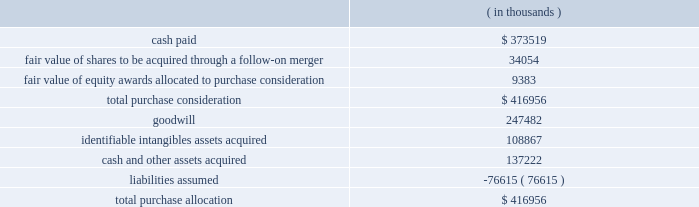Synopsys , inc .
Notes to consolidated financial statements 2014continued the aggregate purchase price consideration was approximately us$ 417.0 million .
As of october 31 , 2012 , the total purchase consideration and the preliminary purchase price allocation were as follows: .
Goodwill of $ 247.5 million , which is generally not deductible for tax purposes , primarily resulted from the company 2019s expectation of sales growth and cost synergies from the integration of springsoft 2019s technology and operations with the company 2019s technology and operations .
Identifiable intangible assets , consisting primarily of technology , customer relationships , backlog and trademarks , were valued using the income method , and are being amortized over three to eight years .
Acquisition-related costs directly attributable to the business combination were $ 6.6 million for fiscal 2012 and were expensed as incurred in the consolidated statements of operations .
These costs consisted primarily of employee separation costs and professional services .
Fair value of equity awards : pursuant to the merger agreement , the company assumed all the unvested outstanding stock options of springsoft upon the completion of the merger and the vested options were exchanged for cash in the merger .
On october 1 , 2012 , the date of the completion of the tender offer , the fair value of the awards to be assumed and exchanged was $ 9.9 million , calculated using the black-scholes option pricing model .
The black-scholes option-pricing model incorporates various subjective assumptions including expected volatility , expected term and risk-free interest rates .
The expected volatility was estimated by a combination of implied and historical stock price volatility of the options .
Non-controlling interest : non-controlling interest represents the fair value of the 8.4% ( 8.4 % ) of outstanding springsoft shares that were not acquired during the tender offer process completed on october 1 , 2012 and the fair value of the option awards that were to be assumed or exchanged for cash upon the follow-on merger .
The fair value of the non-controlling interest included as part of the aggregate purchase consideration was $ 42.8 million and is disclosed as a separate line in the october 31 , 2012 consolidated statements of stockholders 2019 equity .
During the period between the completion of the tender offer and the end of the company 2019s fiscal year on october 31 , 2012 , the non-controlling interest was adjusted by $ 0.5 million to reflect the non-controlling interest 2019s share of the operating loss of springsoft in that period .
As the amount is not significant , it has been included as part of other income ( expense ) , net , in the consolidated statements of operations. .
What is the difference between cash and other assets acquired and liabilities assumed? 
Computations: (137222 - 76615)
Answer: 60607.0. 